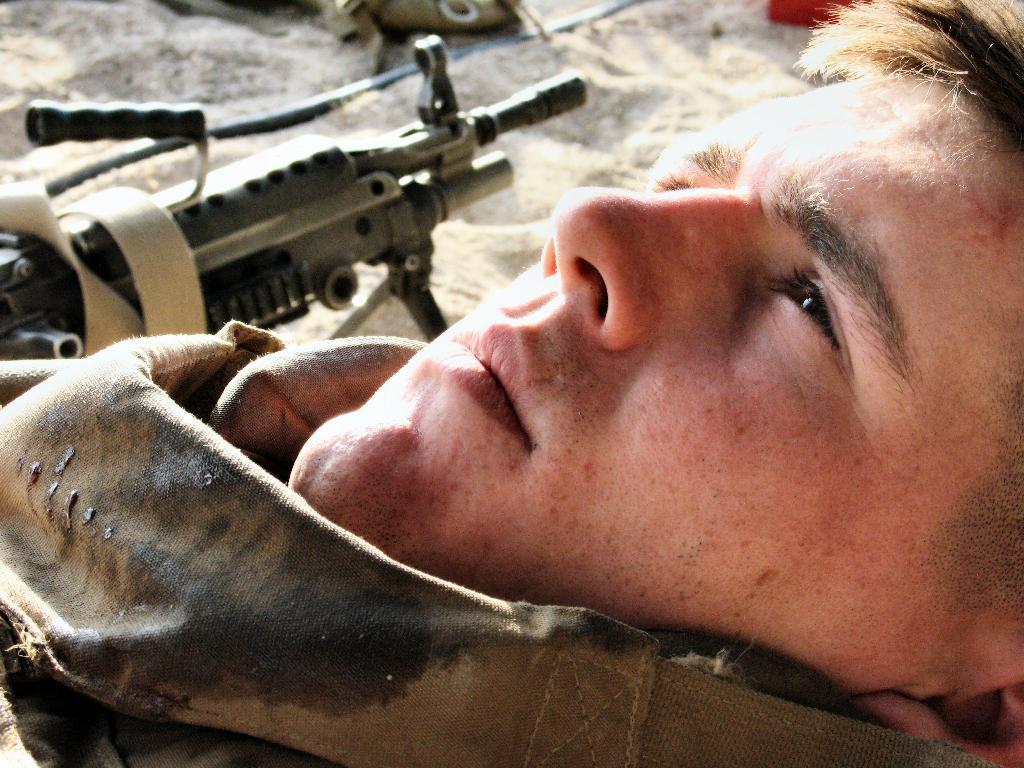In one or two sentences, can you explain what this image depicts? In this image I can see a person wearing military dress. Background I can see a gun and sand. 